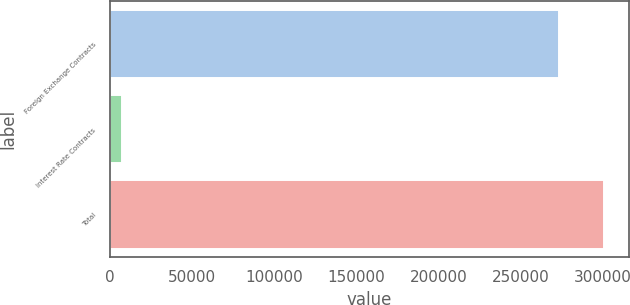<chart> <loc_0><loc_0><loc_500><loc_500><bar_chart><fcel>Foreign Exchange Contracts<fcel>Interest Rate Contracts<fcel>Total<nl><fcel>273213<fcel>6968.3<fcel>300534<nl></chart> 